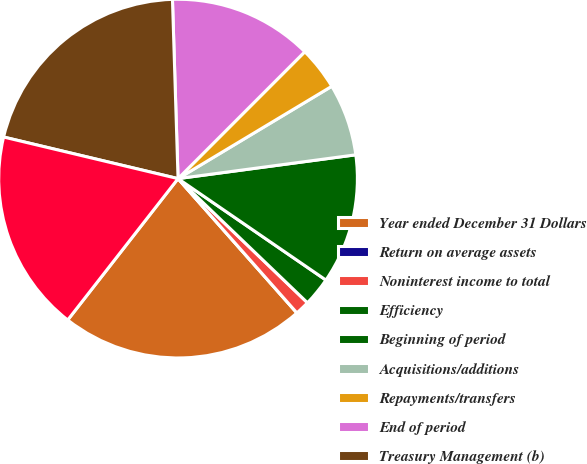Convert chart to OTSL. <chart><loc_0><loc_0><loc_500><loc_500><pie_chart><fcel>Year ended December 31 Dollars<fcel>Return on average assets<fcel>Noninterest income to total<fcel>Efficiency<fcel>Beginning of period<fcel>Acquisitions/additions<fcel>Repayments/transfers<fcel>End of period<fcel>Treasury Management (b)<fcel>Capital Markets (c)<nl><fcel>22.08%<fcel>0.0%<fcel>1.3%<fcel>2.6%<fcel>11.69%<fcel>6.49%<fcel>3.9%<fcel>12.99%<fcel>20.78%<fcel>18.18%<nl></chart> 